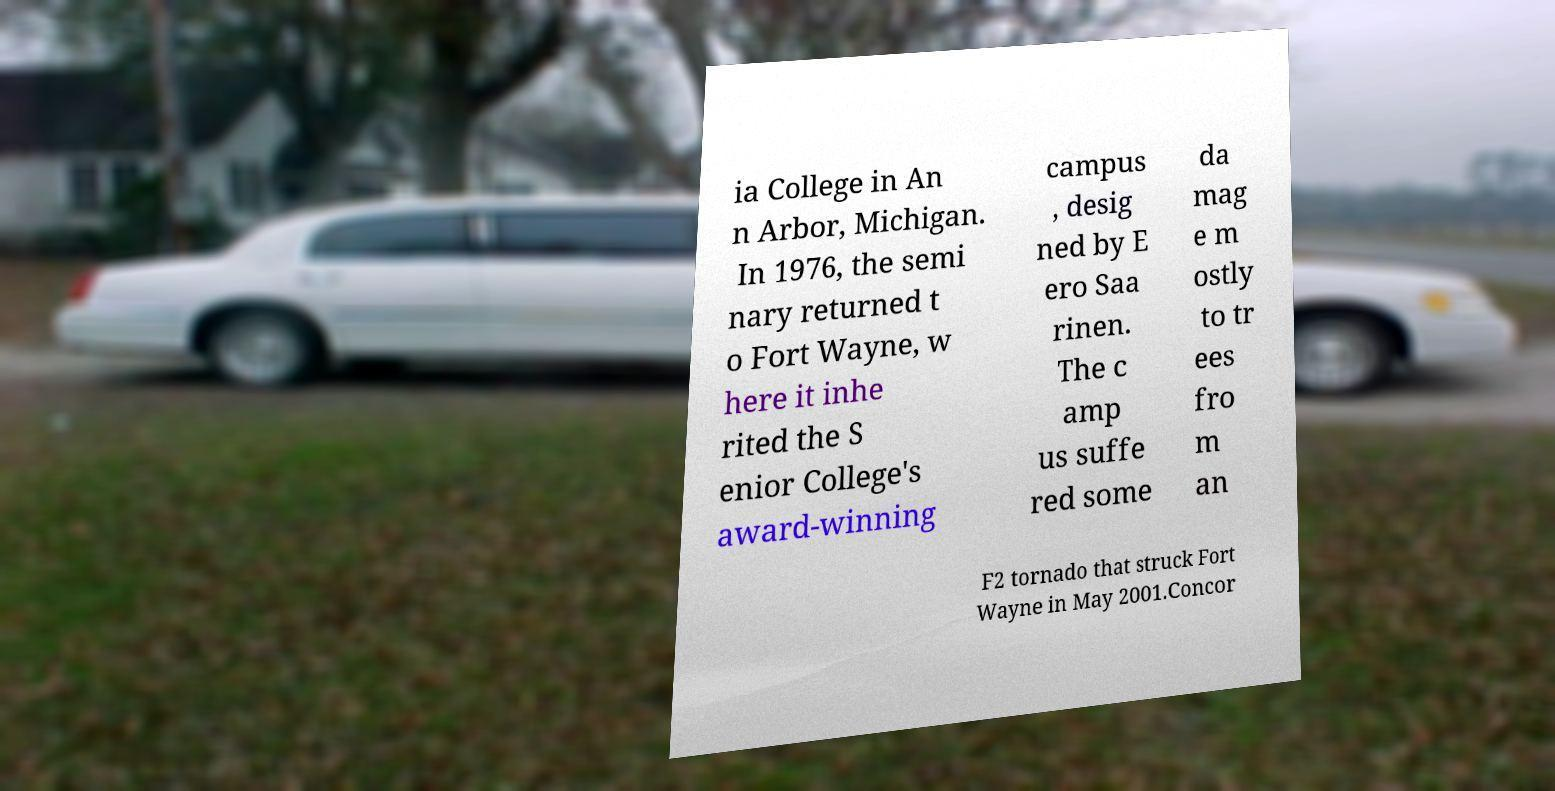There's text embedded in this image that I need extracted. Can you transcribe it verbatim? ia College in An n Arbor, Michigan. In 1976, the semi nary returned t o Fort Wayne, w here it inhe rited the S enior College's award-winning campus , desig ned by E ero Saa rinen. The c amp us suffe red some da mag e m ostly to tr ees fro m an F2 tornado that struck Fort Wayne in May 2001.Concor 